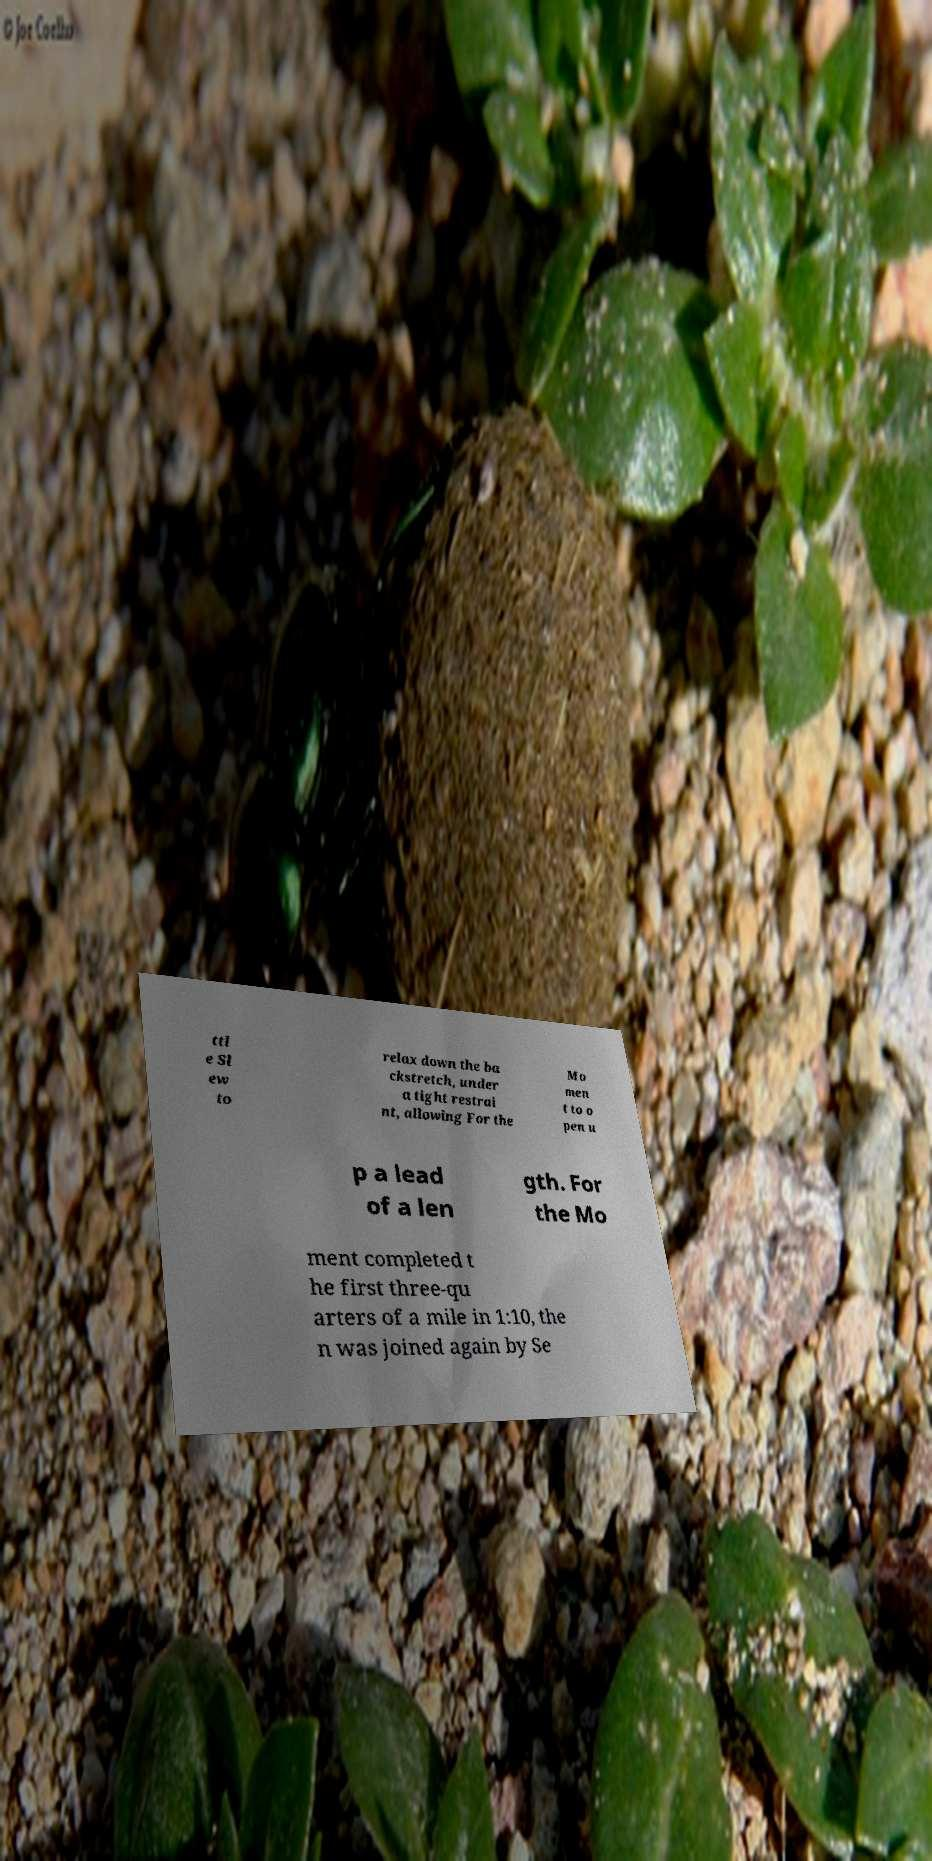Could you extract and type out the text from this image? ttl e Sl ew to relax down the ba ckstretch, under a tight restrai nt, allowing For the Mo men t to o pen u p a lead of a len gth. For the Mo ment completed t he first three-qu arters of a mile in 1:10, the n was joined again by Se 